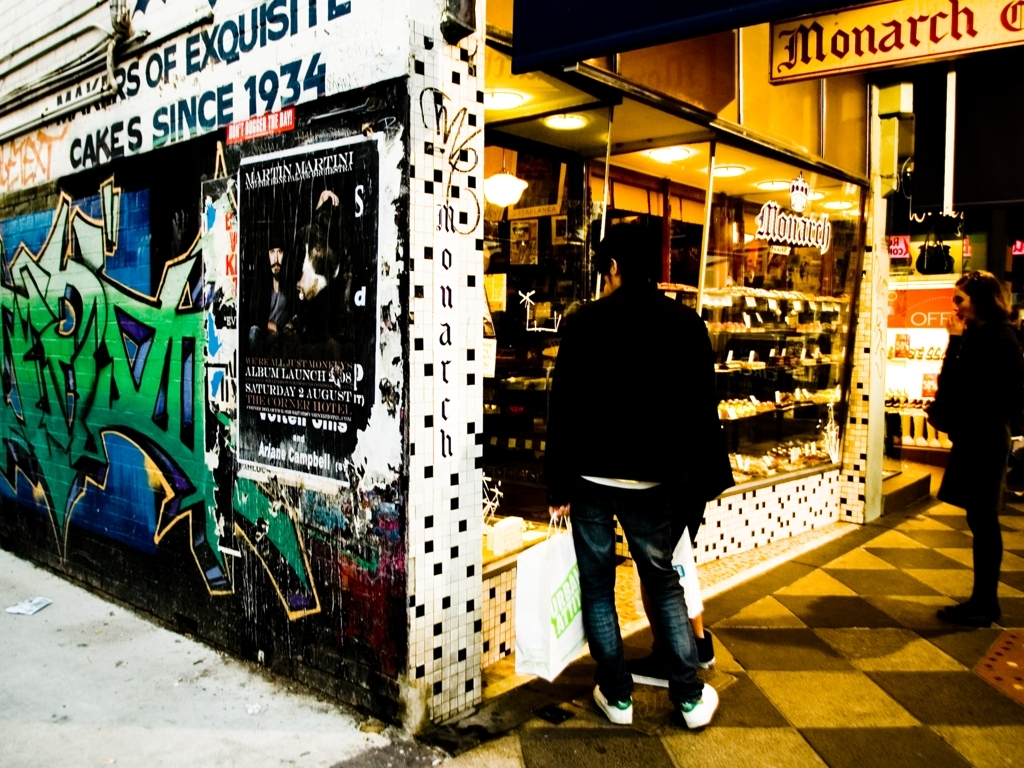Can you infer the time period when this photo might have been taken? While the exact time period is not readily discernible, several clues suggest a modern setting. The presence of graffiti, contemporary clothing styles, and modern shop signage indicate the photo was likely taken within the last few decades. 